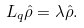Convert formula to latex. <formula><loc_0><loc_0><loc_500><loc_500>L _ { q } \hat { \rho } = \lambda \hat { \rho } .</formula> 